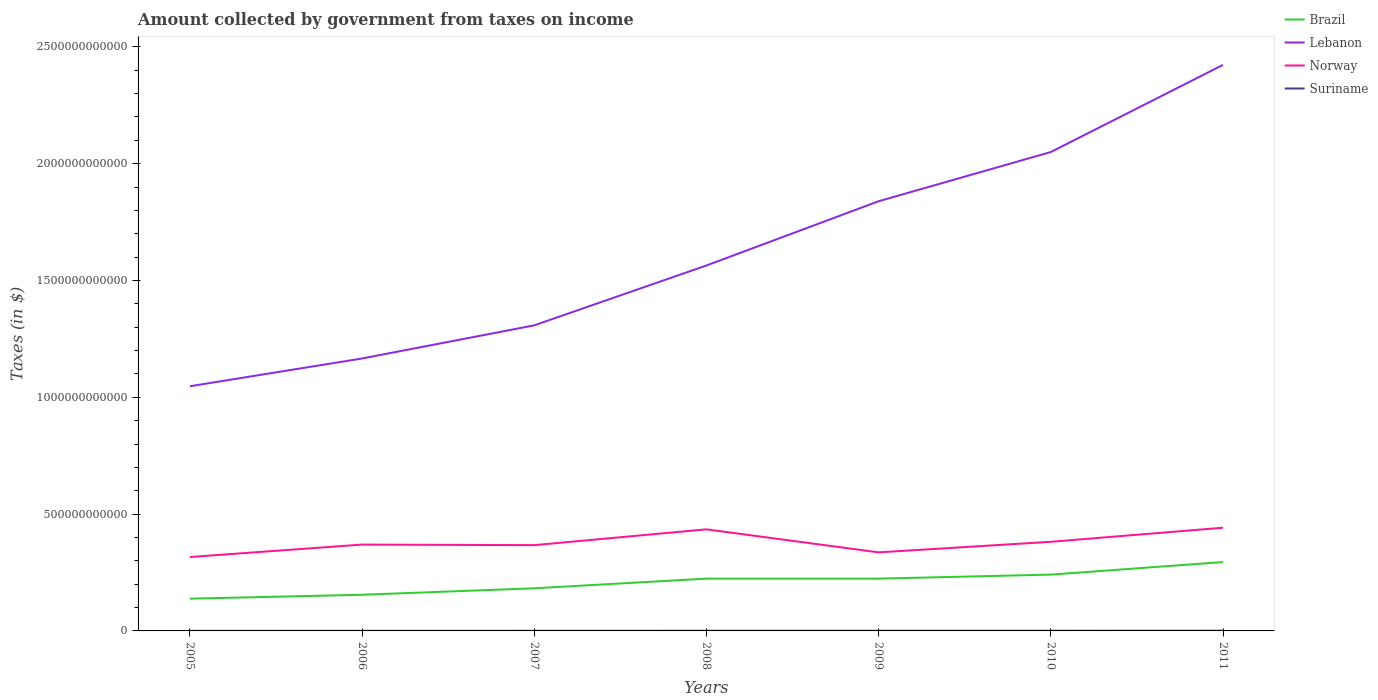How many different coloured lines are there?
Make the answer very short. 4. Across all years, what is the maximum amount collected by government from taxes on income in Lebanon?
Give a very brief answer. 1.05e+12. What is the total amount collected by government from taxes on income in Suriname in the graph?
Offer a very short reply. -3.59e+08. What is the difference between the highest and the second highest amount collected by government from taxes on income in Suriname?
Make the answer very short. 6.50e+08. What is the difference between the highest and the lowest amount collected by government from taxes on income in Brazil?
Offer a very short reply. 4. Is the amount collected by government from taxes on income in Norway strictly greater than the amount collected by government from taxes on income in Brazil over the years?
Your answer should be compact. No. How many lines are there?
Your answer should be compact. 4. How many years are there in the graph?
Offer a very short reply. 7. What is the difference between two consecutive major ticks on the Y-axis?
Provide a succinct answer. 5.00e+11. Does the graph contain any zero values?
Make the answer very short. No. Does the graph contain grids?
Make the answer very short. No. Where does the legend appear in the graph?
Ensure brevity in your answer.  Top right. How are the legend labels stacked?
Offer a very short reply. Vertical. What is the title of the graph?
Keep it short and to the point. Amount collected by government from taxes on income. What is the label or title of the X-axis?
Offer a terse response. Years. What is the label or title of the Y-axis?
Offer a very short reply. Taxes (in $). What is the Taxes (in $) in Brazil in 2005?
Keep it short and to the point. 1.38e+11. What is the Taxes (in $) in Lebanon in 2005?
Your answer should be compact. 1.05e+12. What is the Taxes (in $) of Norway in 2005?
Your response must be concise. 3.16e+11. What is the Taxes (in $) of Suriname in 2005?
Offer a terse response. 3.90e+08. What is the Taxes (in $) in Brazil in 2006?
Your response must be concise. 1.55e+11. What is the Taxes (in $) in Lebanon in 2006?
Provide a short and direct response. 1.17e+12. What is the Taxes (in $) of Norway in 2006?
Provide a succinct answer. 3.70e+11. What is the Taxes (in $) in Suriname in 2006?
Keep it short and to the point. 4.40e+08. What is the Taxes (in $) of Brazil in 2007?
Keep it short and to the point. 1.82e+11. What is the Taxes (in $) in Lebanon in 2007?
Your answer should be very brief. 1.31e+12. What is the Taxes (in $) of Norway in 2007?
Keep it short and to the point. 3.67e+11. What is the Taxes (in $) in Suriname in 2007?
Provide a short and direct response. 5.95e+08. What is the Taxes (in $) of Brazil in 2008?
Offer a very short reply. 2.24e+11. What is the Taxes (in $) of Lebanon in 2008?
Provide a succinct answer. 1.56e+12. What is the Taxes (in $) in Norway in 2008?
Provide a succinct answer. 4.35e+11. What is the Taxes (in $) of Suriname in 2008?
Your answer should be compact. 6.34e+08. What is the Taxes (in $) of Brazil in 2009?
Your response must be concise. 2.24e+11. What is the Taxes (in $) of Lebanon in 2009?
Your answer should be compact. 1.84e+12. What is the Taxes (in $) of Norway in 2009?
Give a very brief answer. 3.36e+11. What is the Taxes (in $) in Suriname in 2009?
Make the answer very short. 7.49e+08. What is the Taxes (in $) in Brazil in 2010?
Keep it short and to the point. 2.41e+11. What is the Taxes (in $) in Lebanon in 2010?
Make the answer very short. 2.05e+12. What is the Taxes (in $) of Norway in 2010?
Provide a succinct answer. 3.81e+11. What is the Taxes (in $) in Suriname in 2010?
Make the answer very short. 7.22e+08. What is the Taxes (in $) of Brazil in 2011?
Offer a terse response. 2.95e+11. What is the Taxes (in $) in Lebanon in 2011?
Your response must be concise. 2.42e+12. What is the Taxes (in $) in Norway in 2011?
Your answer should be compact. 4.42e+11. What is the Taxes (in $) in Suriname in 2011?
Your answer should be very brief. 1.04e+09. Across all years, what is the maximum Taxes (in $) of Brazil?
Your answer should be compact. 2.95e+11. Across all years, what is the maximum Taxes (in $) of Lebanon?
Ensure brevity in your answer.  2.42e+12. Across all years, what is the maximum Taxes (in $) in Norway?
Your answer should be very brief. 4.42e+11. Across all years, what is the maximum Taxes (in $) of Suriname?
Your answer should be very brief. 1.04e+09. Across all years, what is the minimum Taxes (in $) of Brazil?
Make the answer very short. 1.38e+11. Across all years, what is the minimum Taxes (in $) of Lebanon?
Provide a short and direct response. 1.05e+12. Across all years, what is the minimum Taxes (in $) in Norway?
Ensure brevity in your answer.  3.16e+11. Across all years, what is the minimum Taxes (in $) in Suriname?
Keep it short and to the point. 3.90e+08. What is the total Taxes (in $) in Brazil in the graph?
Provide a succinct answer. 1.46e+12. What is the total Taxes (in $) in Lebanon in the graph?
Your answer should be compact. 1.14e+13. What is the total Taxes (in $) of Norway in the graph?
Your answer should be compact. 2.65e+12. What is the total Taxes (in $) of Suriname in the graph?
Offer a terse response. 4.57e+09. What is the difference between the Taxes (in $) in Brazil in 2005 and that in 2006?
Offer a very short reply. -1.67e+1. What is the difference between the Taxes (in $) of Lebanon in 2005 and that in 2006?
Your response must be concise. -1.19e+11. What is the difference between the Taxes (in $) of Norway in 2005 and that in 2006?
Your answer should be compact. -5.32e+1. What is the difference between the Taxes (in $) in Suriname in 2005 and that in 2006?
Provide a succinct answer. -4.96e+07. What is the difference between the Taxes (in $) of Brazil in 2005 and that in 2007?
Keep it short and to the point. -4.44e+1. What is the difference between the Taxes (in $) in Lebanon in 2005 and that in 2007?
Keep it short and to the point. -2.61e+11. What is the difference between the Taxes (in $) in Norway in 2005 and that in 2007?
Your response must be concise. -5.08e+1. What is the difference between the Taxes (in $) of Suriname in 2005 and that in 2007?
Provide a short and direct response. -2.05e+08. What is the difference between the Taxes (in $) of Brazil in 2005 and that in 2008?
Keep it short and to the point. -8.58e+1. What is the difference between the Taxes (in $) in Lebanon in 2005 and that in 2008?
Your answer should be very brief. -5.17e+11. What is the difference between the Taxes (in $) of Norway in 2005 and that in 2008?
Your answer should be very brief. -1.18e+11. What is the difference between the Taxes (in $) of Suriname in 2005 and that in 2008?
Ensure brevity in your answer.  -2.44e+08. What is the difference between the Taxes (in $) in Brazil in 2005 and that in 2009?
Give a very brief answer. -8.58e+1. What is the difference between the Taxes (in $) in Lebanon in 2005 and that in 2009?
Give a very brief answer. -7.92e+11. What is the difference between the Taxes (in $) of Norway in 2005 and that in 2009?
Offer a terse response. -1.99e+1. What is the difference between the Taxes (in $) of Suriname in 2005 and that in 2009?
Offer a very short reply. -3.59e+08. What is the difference between the Taxes (in $) in Brazil in 2005 and that in 2010?
Offer a very short reply. -1.03e+11. What is the difference between the Taxes (in $) in Lebanon in 2005 and that in 2010?
Offer a very short reply. -1.00e+12. What is the difference between the Taxes (in $) of Norway in 2005 and that in 2010?
Keep it short and to the point. -6.51e+1. What is the difference between the Taxes (in $) in Suriname in 2005 and that in 2010?
Give a very brief answer. -3.32e+08. What is the difference between the Taxes (in $) in Brazil in 2005 and that in 2011?
Your answer should be very brief. -1.57e+11. What is the difference between the Taxes (in $) in Lebanon in 2005 and that in 2011?
Your answer should be very brief. -1.38e+12. What is the difference between the Taxes (in $) of Norway in 2005 and that in 2011?
Keep it short and to the point. -1.25e+11. What is the difference between the Taxes (in $) in Suriname in 2005 and that in 2011?
Provide a succinct answer. -6.50e+08. What is the difference between the Taxes (in $) in Brazil in 2006 and that in 2007?
Your answer should be very brief. -2.77e+1. What is the difference between the Taxes (in $) of Lebanon in 2006 and that in 2007?
Ensure brevity in your answer.  -1.42e+11. What is the difference between the Taxes (in $) of Norway in 2006 and that in 2007?
Provide a short and direct response. 2.41e+09. What is the difference between the Taxes (in $) of Suriname in 2006 and that in 2007?
Offer a terse response. -1.55e+08. What is the difference between the Taxes (in $) of Brazil in 2006 and that in 2008?
Keep it short and to the point. -6.91e+1. What is the difference between the Taxes (in $) in Lebanon in 2006 and that in 2008?
Provide a short and direct response. -3.98e+11. What is the difference between the Taxes (in $) in Norway in 2006 and that in 2008?
Offer a terse response. -6.52e+1. What is the difference between the Taxes (in $) in Suriname in 2006 and that in 2008?
Provide a short and direct response. -1.94e+08. What is the difference between the Taxes (in $) in Brazil in 2006 and that in 2009?
Provide a short and direct response. -6.91e+1. What is the difference between the Taxes (in $) in Lebanon in 2006 and that in 2009?
Provide a succinct answer. -6.73e+11. What is the difference between the Taxes (in $) in Norway in 2006 and that in 2009?
Offer a terse response. 3.33e+1. What is the difference between the Taxes (in $) of Suriname in 2006 and that in 2009?
Ensure brevity in your answer.  -3.10e+08. What is the difference between the Taxes (in $) in Brazil in 2006 and that in 2010?
Give a very brief answer. -8.63e+1. What is the difference between the Taxes (in $) of Lebanon in 2006 and that in 2010?
Make the answer very short. -8.84e+11. What is the difference between the Taxes (in $) in Norway in 2006 and that in 2010?
Your answer should be compact. -1.19e+1. What is the difference between the Taxes (in $) of Suriname in 2006 and that in 2010?
Provide a short and direct response. -2.83e+08. What is the difference between the Taxes (in $) of Brazil in 2006 and that in 2011?
Offer a very short reply. -1.40e+11. What is the difference between the Taxes (in $) in Lebanon in 2006 and that in 2011?
Your answer should be very brief. -1.26e+12. What is the difference between the Taxes (in $) of Norway in 2006 and that in 2011?
Provide a succinct answer. -7.22e+1. What is the difference between the Taxes (in $) in Suriname in 2006 and that in 2011?
Give a very brief answer. -6.01e+08. What is the difference between the Taxes (in $) in Brazil in 2007 and that in 2008?
Your response must be concise. -4.14e+1. What is the difference between the Taxes (in $) of Lebanon in 2007 and that in 2008?
Your answer should be very brief. -2.56e+11. What is the difference between the Taxes (in $) in Norway in 2007 and that in 2008?
Make the answer very short. -6.76e+1. What is the difference between the Taxes (in $) in Suriname in 2007 and that in 2008?
Provide a succinct answer. -3.89e+07. What is the difference between the Taxes (in $) in Brazil in 2007 and that in 2009?
Ensure brevity in your answer.  -4.14e+1. What is the difference between the Taxes (in $) of Lebanon in 2007 and that in 2009?
Make the answer very short. -5.31e+11. What is the difference between the Taxes (in $) in Norway in 2007 and that in 2009?
Give a very brief answer. 3.09e+1. What is the difference between the Taxes (in $) in Suriname in 2007 and that in 2009?
Give a very brief answer. -1.55e+08. What is the difference between the Taxes (in $) in Brazil in 2007 and that in 2010?
Your answer should be compact. -5.86e+1. What is the difference between the Taxes (in $) in Lebanon in 2007 and that in 2010?
Your answer should be compact. -7.42e+11. What is the difference between the Taxes (in $) of Norway in 2007 and that in 2010?
Ensure brevity in your answer.  -1.43e+1. What is the difference between the Taxes (in $) of Suriname in 2007 and that in 2010?
Your answer should be compact. -1.28e+08. What is the difference between the Taxes (in $) of Brazil in 2007 and that in 2011?
Make the answer very short. -1.12e+11. What is the difference between the Taxes (in $) of Lebanon in 2007 and that in 2011?
Your response must be concise. -1.11e+12. What is the difference between the Taxes (in $) in Norway in 2007 and that in 2011?
Provide a succinct answer. -7.46e+1. What is the difference between the Taxes (in $) of Suriname in 2007 and that in 2011?
Your response must be concise. -4.46e+08. What is the difference between the Taxes (in $) of Brazil in 2008 and that in 2009?
Your answer should be compact. 1.68e+07. What is the difference between the Taxes (in $) in Lebanon in 2008 and that in 2009?
Provide a short and direct response. -2.75e+11. What is the difference between the Taxes (in $) of Norway in 2008 and that in 2009?
Offer a very short reply. 9.85e+1. What is the difference between the Taxes (in $) of Suriname in 2008 and that in 2009?
Provide a succinct answer. -1.16e+08. What is the difference between the Taxes (in $) of Brazil in 2008 and that in 2010?
Your answer should be very brief. -1.72e+1. What is the difference between the Taxes (in $) in Lebanon in 2008 and that in 2010?
Make the answer very short. -4.86e+11. What is the difference between the Taxes (in $) in Norway in 2008 and that in 2010?
Make the answer very short. 5.33e+1. What is the difference between the Taxes (in $) in Suriname in 2008 and that in 2010?
Ensure brevity in your answer.  -8.88e+07. What is the difference between the Taxes (in $) of Brazil in 2008 and that in 2011?
Provide a short and direct response. -7.09e+1. What is the difference between the Taxes (in $) in Lebanon in 2008 and that in 2011?
Ensure brevity in your answer.  -8.59e+11. What is the difference between the Taxes (in $) of Norway in 2008 and that in 2011?
Your answer should be very brief. -6.99e+09. What is the difference between the Taxes (in $) in Suriname in 2008 and that in 2011?
Provide a short and direct response. -4.07e+08. What is the difference between the Taxes (in $) of Brazil in 2009 and that in 2010?
Provide a succinct answer. -1.72e+1. What is the difference between the Taxes (in $) in Lebanon in 2009 and that in 2010?
Offer a terse response. -2.11e+11. What is the difference between the Taxes (in $) of Norway in 2009 and that in 2010?
Ensure brevity in your answer.  -4.52e+1. What is the difference between the Taxes (in $) of Suriname in 2009 and that in 2010?
Make the answer very short. 2.70e+07. What is the difference between the Taxes (in $) of Brazil in 2009 and that in 2011?
Make the answer very short. -7.09e+1. What is the difference between the Taxes (in $) in Lebanon in 2009 and that in 2011?
Provide a succinct answer. -5.84e+11. What is the difference between the Taxes (in $) in Norway in 2009 and that in 2011?
Make the answer very short. -1.05e+11. What is the difference between the Taxes (in $) of Suriname in 2009 and that in 2011?
Give a very brief answer. -2.91e+08. What is the difference between the Taxes (in $) of Brazil in 2010 and that in 2011?
Your response must be concise. -5.37e+1. What is the difference between the Taxes (in $) in Lebanon in 2010 and that in 2011?
Your answer should be compact. -3.73e+11. What is the difference between the Taxes (in $) in Norway in 2010 and that in 2011?
Ensure brevity in your answer.  -6.03e+1. What is the difference between the Taxes (in $) of Suriname in 2010 and that in 2011?
Offer a very short reply. -3.18e+08. What is the difference between the Taxes (in $) of Brazil in 2005 and the Taxes (in $) of Lebanon in 2006?
Offer a very short reply. -1.03e+12. What is the difference between the Taxes (in $) in Brazil in 2005 and the Taxes (in $) in Norway in 2006?
Make the answer very short. -2.32e+11. What is the difference between the Taxes (in $) in Brazil in 2005 and the Taxes (in $) in Suriname in 2006?
Your answer should be compact. 1.38e+11. What is the difference between the Taxes (in $) in Lebanon in 2005 and the Taxes (in $) in Norway in 2006?
Provide a short and direct response. 6.78e+11. What is the difference between the Taxes (in $) in Lebanon in 2005 and the Taxes (in $) in Suriname in 2006?
Provide a succinct answer. 1.05e+12. What is the difference between the Taxes (in $) of Norway in 2005 and the Taxes (in $) of Suriname in 2006?
Ensure brevity in your answer.  3.16e+11. What is the difference between the Taxes (in $) in Brazil in 2005 and the Taxes (in $) in Lebanon in 2007?
Your answer should be compact. -1.17e+12. What is the difference between the Taxes (in $) in Brazil in 2005 and the Taxes (in $) in Norway in 2007?
Ensure brevity in your answer.  -2.29e+11. What is the difference between the Taxes (in $) of Brazil in 2005 and the Taxes (in $) of Suriname in 2007?
Your response must be concise. 1.37e+11. What is the difference between the Taxes (in $) of Lebanon in 2005 and the Taxes (in $) of Norway in 2007?
Offer a very short reply. 6.80e+11. What is the difference between the Taxes (in $) of Lebanon in 2005 and the Taxes (in $) of Suriname in 2007?
Your response must be concise. 1.05e+12. What is the difference between the Taxes (in $) in Norway in 2005 and the Taxes (in $) in Suriname in 2007?
Your answer should be very brief. 3.16e+11. What is the difference between the Taxes (in $) of Brazil in 2005 and the Taxes (in $) of Lebanon in 2008?
Offer a terse response. -1.43e+12. What is the difference between the Taxes (in $) of Brazil in 2005 and the Taxes (in $) of Norway in 2008?
Your answer should be compact. -2.97e+11. What is the difference between the Taxes (in $) of Brazil in 2005 and the Taxes (in $) of Suriname in 2008?
Keep it short and to the point. 1.37e+11. What is the difference between the Taxes (in $) in Lebanon in 2005 and the Taxes (in $) in Norway in 2008?
Give a very brief answer. 6.13e+11. What is the difference between the Taxes (in $) of Lebanon in 2005 and the Taxes (in $) of Suriname in 2008?
Make the answer very short. 1.05e+12. What is the difference between the Taxes (in $) in Norway in 2005 and the Taxes (in $) in Suriname in 2008?
Make the answer very short. 3.16e+11. What is the difference between the Taxes (in $) of Brazil in 2005 and the Taxes (in $) of Lebanon in 2009?
Offer a very short reply. -1.70e+12. What is the difference between the Taxes (in $) of Brazil in 2005 and the Taxes (in $) of Norway in 2009?
Your answer should be very brief. -1.98e+11. What is the difference between the Taxes (in $) of Brazil in 2005 and the Taxes (in $) of Suriname in 2009?
Offer a terse response. 1.37e+11. What is the difference between the Taxes (in $) of Lebanon in 2005 and the Taxes (in $) of Norway in 2009?
Your answer should be very brief. 7.11e+11. What is the difference between the Taxes (in $) in Lebanon in 2005 and the Taxes (in $) in Suriname in 2009?
Your answer should be compact. 1.05e+12. What is the difference between the Taxes (in $) in Norway in 2005 and the Taxes (in $) in Suriname in 2009?
Your answer should be compact. 3.16e+11. What is the difference between the Taxes (in $) in Brazil in 2005 and the Taxes (in $) in Lebanon in 2010?
Offer a very short reply. -1.91e+12. What is the difference between the Taxes (in $) in Brazil in 2005 and the Taxes (in $) in Norway in 2010?
Give a very brief answer. -2.43e+11. What is the difference between the Taxes (in $) of Brazil in 2005 and the Taxes (in $) of Suriname in 2010?
Keep it short and to the point. 1.37e+11. What is the difference between the Taxes (in $) in Lebanon in 2005 and the Taxes (in $) in Norway in 2010?
Give a very brief answer. 6.66e+11. What is the difference between the Taxes (in $) of Lebanon in 2005 and the Taxes (in $) of Suriname in 2010?
Your response must be concise. 1.05e+12. What is the difference between the Taxes (in $) in Norway in 2005 and the Taxes (in $) in Suriname in 2010?
Give a very brief answer. 3.16e+11. What is the difference between the Taxes (in $) in Brazil in 2005 and the Taxes (in $) in Lebanon in 2011?
Keep it short and to the point. -2.28e+12. What is the difference between the Taxes (in $) in Brazil in 2005 and the Taxes (in $) in Norway in 2011?
Ensure brevity in your answer.  -3.04e+11. What is the difference between the Taxes (in $) in Brazil in 2005 and the Taxes (in $) in Suriname in 2011?
Your response must be concise. 1.37e+11. What is the difference between the Taxes (in $) in Lebanon in 2005 and the Taxes (in $) in Norway in 2011?
Your response must be concise. 6.06e+11. What is the difference between the Taxes (in $) of Lebanon in 2005 and the Taxes (in $) of Suriname in 2011?
Your response must be concise. 1.05e+12. What is the difference between the Taxes (in $) in Norway in 2005 and the Taxes (in $) in Suriname in 2011?
Provide a short and direct response. 3.15e+11. What is the difference between the Taxes (in $) of Brazil in 2006 and the Taxes (in $) of Lebanon in 2007?
Offer a very short reply. -1.15e+12. What is the difference between the Taxes (in $) in Brazil in 2006 and the Taxes (in $) in Norway in 2007?
Give a very brief answer. -2.12e+11. What is the difference between the Taxes (in $) in Brazil in 2006 and the Taxes (in $) in Suriname in 2007?
Your answer should be compact. 1.54e+11. What is the difference between the Taxes (in $) of Lebanon in 2006 and the Taxes (in $) of Norway in 2007?
Make the answer very short. 7.99e+11. What is the difference between the Taxes (in $) in Lebanon in 2006 and the Taxes (in $) in Suriname in 2007?
Your answer should be very brief. 1.17e+12. What is the difference between the Taxes (in $) in Norway in 2006 and the Taxes (in $) in Suriname in 2007?
Offer a very short reply. 3.69e+11. What is the difference between the Taxes (in $) in Brazil in 2006 and the Taxes (in $) in Lebanon in 2008?
Your answer should be very brief. -1.41e+12. What is the difference between the Taxes (in $) in Brazil in 2006 and the Taxes (in $) in Norway in 2008?
Give a very brief answer. -2.80e+11. What is the difference between the Taxes (in $) in Brazil in 2006 and the Taxes (in $) in Suriname in 2008?
Your answer should be compact. 1.54e+11. What is the difference between the Taxes (in $) of Lebanon in 2006 and the Taxes (in $) of Norway in 2008?
Your answer should be very brief. 7.31e+11. What is the difference between the Taxes (in $) of Lebanon in 2006 and the Taxes (in $) of Suriname in 2008?
Provide a short and direct response. 1.17e+12. What is the difference between the Taxes (in $) in Norway in 2006 and the Taxes (in $) in Suriname in 2008?
Make the answer very short. 3.69e+11. What is the difference between the Taxes (in $) in Brazil in 2006 and the Taxes (in $) in Lebanon in 2009?
Your answer should be very brief. -1.68e+12. What is the difference between the Taxes (in $) in Brazil in 2006 and the Taxes (in $) in Norway in 2009?
Keep it short and to the point. -1.82e+11. What is the difference between the Taxes (in $) in Brazil in 2006 and the Taxes (in $) in Suriname in 2009?
Your answer should be very brief. 1.54e+11. What is the difference between the Taxes (in $) in Lebanon in 2006 and the Taxes (in $) in Norway in 2009?
Offer a terse response. 8.30e+11. What is the difference between the Taxes (in $) in Lebanon in 2006 and the Taxes (in $) in Suriname in 2009?
Provide a succinct answer. 1.17e+12. What is the difference between the Taxes (in $) in Norway in 2006 and the Taxes (in $) in Suriname in 2009?
Offer a very short reply. 3.69e+11. What is the difference between the Taxes (in $) in Brazil in 2006 and the Taxes (in $) in Lebanon in 2010?
Offer a terse response. -1.90e+12. What is the difference between the Taxes (in $) in Brazil in 2006 and the Taxes (in $) in Norway in 2010?
Your response must be concise. -2.27e+11. What is the difference between the Taxes (in $) in Brazil in 2006 and the Taxes (in $) in Suriname in 2010?
Give a very brief answer. 1.54e+11. What is the difference between the Taxes (in $) in Lebanon in 2006 and the Taxes (in $) in Norway in 2010?
Offer a terse response. 7.85e+11. What is the difference between the Taxes (in $) of Lebanon in 2006 and the Taxes (in $) of Suriname in 2010?
Your answer should be very brief. 1.17e+12. What is the difference between the Taxes (in $) in Norway in 2006 and the Taxes (in $) in Suriname in 2010?
Provide a succinct answer. 3.69e+11. What is the difference between the Taxes (in $) in Brazil in 2006 and the Taxes (in $) in Lebanon in 2011?
Give a very brief answer. -2.27e+12. What is the difference between the Taxes (in $) in Brazil in 2006 and the Taxes (in $) in Norway in 2011?
Your answer should be compact. -2.87e+11. What is the difference between the Taxes (in $) of Brazil in 2006 and the Taxes (in $) of Suriname in 2011?
Give a very brief answer. 1.54e+11. What is the difference between the Taxes (in $) in Lebanon in 2006 and the Taxes (in $) in Norway in 2011?
Provide a succinct answer. 7.24e+11. What is the difference between the Taxes (in $) in Lebanon in 2006 and the Taxes (in $) in Suriname in 2011?
Keep it short and to the point. 1.17e+12. What is the difference between the Taxes (in $) of Norway in 2006 and the Taxes (in $) of Suriname in 2011?
Give a very brief answer. 3.69e+11. What is the difference between the Taxes (in $) of Brazil in 2007 and the Taxes (in $) of Lebanon in 2008?
Ensure brevity in your answer.  -1.38e+12. What is the difference between the Taxes (in $) of Brazil in 2007 and the Taxes (in $) of Norway in 2008?
Your answer should be compact. -2.52e+11. What is the difference between the Taxes (in $) of Brazil in 2007 and the Taxes (in $) of Suriname in 2008?
Your answer should be very brief. 1.82e+11. What is the difference between the Taxes (in $) of Lebanon in 2007 and the Taxes (in $) of Norway in 2008?
Give a very brief answer. 8.73e+11. What is the difference between the Taxes (in $) in Lebanon in 2007 and the Taxes (in $) in Suriname in 2008?
Your answer should be very brief. 1.31e+12. What is the difference between the Taxes (in $) of Norway in 2007 and the Taxes (in $) of Suriname in 2008?
Provide a short and direct response. 3.67e+11. What is the difference between the Taxes (in $) in Brazil in 2007 and the Taxes (in $) in Lebanon in 2009?
Your answer should be compact. -1.66e+12. What is the difference between the Taxes (in $) of Brazil in 2007 and the Taxes (in $) of Norway in 2009?
Your answer should be very brief. -1.54e+11. What is the difference between the Taxes (in $) in Brazil in 2007 and the Taxes (in $) in Suriname in 2009?
Offer a very short reply. 1.82e+11. What is the difference between the Taxes (in $) of Lebanon in 2007 and the Taxes (in $) of Norway in 2009?
Make the answer very short. 9.72e+11. What is the difference between the Taxes (in $) in Lebanon in 2007 and the Taxes (in $) in Suriname in 2009?
Your response must be concise. 1.31e+12. What is the difference between the Taxes (in $) in Norway in 2007 and the Taxes (in $) in Suriname in 2009?
Provide a short and direct response. 3.66e+11. What is the difference between the Taxes (in $) in Brazil in 2007 and the Taxes (in $) in Lebanon in 2010?
Make the answer very short. -1.87e+12. What is the difference between the Taxes (in $) in Brazil in 2007 and the Taxes (in $) in Norway in 2010?
Provide a short and direct response. -1.99e+11. What is the difference between the Taxes (in $) in Brazil in 2007 and the Taxes (in $) in Suriname in 2010?
Make the answer very short. 1.82e+11. What is the difference between the Taxes (in $) in Lebanon in 2007 and the Taxes (in $) in Norway in 2010?
Offer a terse response. 9.27e+11. What is the difference between the Taxes (in $) of Lebanon in 2007 and the Taxes (in $) of Suriname in 2010?
Your response must be concise. 1.31e+12. What is the difference between the Taxes (in $) of Norway in 2007 and the Taxes (in $) of Suriname in 2010?
Make the answer very short. 3.66e+11. What is the difference between the Taxes (in $) of Brazil in 2007 and the Taxes (in $) of Lebanon in 2011?
Your answer should be compact. -2.24e+12. What is the difference between the Taxes (in $) of Brazil in 2007 and the Taxes (in $) of Norway in 2011?
Ensure brevity in your answer.  -2.59e+11. What is the difference between the Taxes (in $) in Brazil in 2007 and the Taxes (in $) in Suriname in 2011?
Offer a very short reply. 1.81e+11. What is the difference between the Taxes (in $) of Lebanon in 2007 and the Taxes (in $) of Norway in 2011?
Your response must be concise. 8.66e+11. What is the difference between the Taxes (in $) of Lebanon in 2007 and the Taxes (in $) of Suriname in 2011?
Provide a short and direct response. 1.31e+12. What is the difference between the Taxes (in $) of Norway in 2007 and the Taxes (in $) of Suriname in 2011?
Provide a succinct answer. 3.66e+11. What is the difference between the Taxes (in $) of Brazil in 2008 and the Taxes (in $) of Lebanon in 2009?
Your response must be concise. -1.62e+12. What is the difference between the Taxes (in $) of Brazil in 2008 and the Taxes (in $) of Norway in 2009?
Provide a short and direct response. -1.12e+11. What is the difference between the Taxes (in $) of Brazil in 2008 and the Taxes (in $) of Suriname in 2009?
Your answer should be compact. 2.23e+11. What is the difference between the Taxes (in $) in Lebanon in 2008 and the Taxes (in $) in Norway in 2009?
Provide a short and direct response. 1.23e+12. What is the difference between the Taxes (in $) in Lebanon in 2008 and the Taxes (in $) in Suriname in 2009?
Ensure brevity in your answer.  1.56e+12. What is the difference between the Taxes (in $) of Norway in 2008 and the Taxes (in $) of Suriname in 2009?
Give a very brief answer. 4.34e+11. What is the difference between the Taxes (in $) of Brazil in 2008 and the Taxes (in $) of Lebanon in 2010?
Keep it short and to the point. -1.83e+12. What is the difference between the Taxes (in $) in Brazil in 2008 and the Taxes (in $) in Norway in 2010?
Keep it short and to the point. -1.58e+11. What is the difference between the Taxes (in $) of Brazil in 2008 and the Taxes (in $) of Suriname in 2010?
Provide a succinct answer. 2.23e+11. What is the difference between the Taxes (in $) in Lebanon in 2008 and the Taxes (in $) in Norway in 2010?
Your answer should be very brief. 1.18e+12. What is the difference between the Taxes (in $) of Lebanon in 2008 and the Taxes (in $) of Suriname in 2010?
Keep it short and to the point. 1.56e+12. What is the difference between the Taxes (in $) in Norway in 2008 and the Taxes (in $) in Suriname in 2010?
Provide a succinct answer. 4.34e+11. What is the difference between the Taxes (in $) in Brazil in 2008 and the Taxes (in $) in Lebanon in 2011?
Provide a short and direct response. -2.20e+12. What is the difference between the Taxes (in $) in Brazil in 2008 and the Taxes (in $) in Norway in 2011?
Provide a short and direct response. -2.18e+11. What is the difference between the Taxes (in $) of Brazil in 2008 and the Taxes (in $) of Suriname in 2011?
Your answer should be very brief. 2.23e+11. What is the difference between the Taxes (in $) in Lebanon in 2008 and the Taxes (in $) in Norway in 2011?
Ensure brevity in your answer.  1.12e+12. What is the difference between the Taxes (in $) in Lebanon in 2008 and the Taxes (in $) in Suriname in 2011?
Keep it short and to the point. 1.56e+12. What is the difference between the Taxes (in $) in Norway in 2008 and the Taxes (in $) in Suriname in 2011?
Ensure brevity in your answer.  4.34e+11. What is the difference between the Taxes (in $) of Brazil in 2009 and the Taxes (in $) of Lebanon in 2010?
Make the answer very short. -1.83e+12. What is the difference between the Taxes (in $) in Brazil in 2009 and the Taxes (in $) in Norway in 2010?
Keep it short and to the point. -1.58e+11. What is the difference between the Taxes (in $) of Brazil in 2009 and the Taxes (in $) of Suriname in 2010?
Provide a succinct answer. 2.23e+11. What is the difference between the Taxes (in $) of Lebanon in 2009 and the Taxes (in $) of Norway in 2010?
Offer a terse response. 1.46e+12. What is the difference between the Taxes (in $) of Lebanon in 2009 and the Taxes (in $) of Suriname in 2010?
Your response must be concise. 1.84e+12. What is the difference between the Taxes (in $) of Norway in 2009 and the Taxes (in $) of Suriname in 2010?
Provide a short and direct response. 3.36e+11. What is the difference between the Taxes (in $) of Brazil in 2009 and the Taxes (in $) of Lebanon in 2011?
Ensure brevity in your answer.  -2.20e+12. What is the difference between the Taxes (in $) in Brazil in 2009 and the Taxes (in $) in Norway in 2011?
Your response must be concise. -2.18e+11. What is the difference between the Taxes (in $) in Brazil in 2009 and the Taxes (in $) in Suriname in 2011?
Make the answer very short. 2.23e+11. What is the difference between the Taxes (in $) in Lebanon in 2009 and the Taxes (in $) in Norway in 2011?
Make the answer very short. 1.40e+12. What is the difference between the Taxes (in $) of Lebanon in 2009 and the Taxes (in $) of Suriname in 2011?
Make the answer very short. 1.84e+12. What is the difference between the Taxes (in $) of Norway in 2009 and the Taxes (in $) of Suriname in 2011?
Offer a very short reply. 3.35e+11. What is the difference between the Taxes (in $) of Brazil in 2010 and the Taxes (in $) of Lebanon in 2011?
Your answer should be very brief. -2.18e+12. What is the difference between the Taxes (in $) in Brazil in 2010 and the Taxes (in $) in Norway in 2011?
Offer a terse response. -2.01e+11. What is the difference between the Taxes (in $) in Brazil in 2010 and the Taxes (in $) in Suriname in 2011?
Make the answer very short. 2.40e+11. What is the difference between the Taxes (in $) of Lebanon in 2010 and the Taxes (in $) of Norway in 2011?
Offer a very short reply. 1.61e+12. What is the difference between the Taxes (in $) of Lebanon in 2010 and the Taxes (in $) of Suriname in 2011?
Your answer should be very brief. 2.05e+12. What is the difference between the Taxes (in $) of Norway in 2010 and the Taxes (in $) of Suriname in 2011?
Keep it short and to the point. 3.80e+11. What is the average Taxes (in $) in Brazil per year?
Your answer should be very brief. 2.08e+11. What is the average Taxes (in $) of Lebanon per year?
Your answer should be compact. 1.63e+12. What is the average Taxes (in $) in Norway per year?
Your response must be concise. 3.78e+11. What is the average Taxes (in $) of Suriname per year?
Your answer should be compact. 6.53e+08. In the year 2005, what is the difference between the Taxes (in $) in Brazil and Taxes (in $) in Lebanon?
Give a very brief answer. -9.09e+11. In the year 2005, what is the difference between the Taxes (in $) of Brazil and Taxes (in $) of Norway?
Your answer should be compact. -1.78e+11. In the year 2005, what is the difference between the Taxes (in $) in Brazil and Taxes (in $) in Suriname?
Ensure brevity in your answer.  1.38e+11. In the year 2005, what is the difference between the Taxes (in $) in Lebanon and Taxes (in $) in Norway?
Your answer should be very brief. 7.31e+11. In the year 2005, what is the difference between the Taxes (in $) of Lebanon and Taxes (in $) of Suriname?
Your answer should be compact. 1.05e+12. In the year 2005, what is the difference between the Taxes (in $) of Norway and Taxes (in $) of Suriname?
Provide a short and direct response. 3.16e+11. In the year 2006, what is the difference between the Taxes (in $) of Brazil and Taxes (in $) of Lebanon?
Keep it short and to the point. -1.01e+12. In the year 2006, what is the difference between the Taxes (in $) in Brazil and Taxes (in $) in Norway?
Provide a short and direct response. -2.15e+11. In the year 2006, what is the difference between the Taxes (in $) of Brazil and Taxes (in $) of Suriname?
Make the answer very short. 1.54e+11. In the year 2006, what is the difference between the Taxes (in $) of Lebanon and Taxes (in $) of Norway?
Your answer should be very brief. 7.97e+11. In the year 2006, what is the difference between the Taxes (in $) of Lebanon and Taxes (in $) of Suriname?
Your answer should be very brief. 1.17e+12. In the year 2006, what is the difference between the Taxes (in $) of Norway and Taxes (in $) of Suriname?
Offer a terse response. 3.69e+11. In the year 2007, what is the difference between the Taxes (in $) in Brazil and Taxes (in $) in Lebanon?
Your answer should be compact. -1.13e+12. In the year 2007, what is the difference between the Taxes (in $) of Brazil and Taxes (in $) of Norway?
Provide a short and direct response. -1.85e+11. In the year 2007, what is the difference between the Taxes (in $) of Brazil and Taxes (in $) of Suriname?
Provide a short and direct response. 1.82e+11. In the year 2007, what is the difference between the Taxes (in $) of Lebanon and Taxes (in $) of Norway?
Give a very brief answer. 9.41e+11. In the year 2007, what is the difference between the Taxes (in $) of Lebanon and Taxes (in $) of Suriname?
Offer a very short reply. 1.31e+12. In the year 2007, what is the difference between the Taxes (in $) in Norway and Taxes (in $) in Suriname?
Give a very brief answer. 3.67e+11. In the year 2008, what is the difference between the Taxes (in $) in Brazil and Taxes (in $) in Lebanon?
Provide a succinct answer. -1.34e+12. In the year 2008, what is the difference between the Taxes (in $) in Brazil and Taxes (in $) in Norway?
Keep it short and to the point. -2.11e+11. In the year 2008, what is the difference between the Taxes (in $) in Brazil and Taxes (in $) in Suriname?
Your answer should be compact. 2.23e+11. In the year 2008, what is the difference between the Taxes (in $) in Lebanon and Taxes (in $) in Norway?
Your response must be concise. 1.13e+12. In the year 2008, what is the difference between the Taxes (in $) in Lebanon and Taxes (in $) in Suriname?
Provide a short and direct response. 1.56e+12. In the year 2008, what is the difference between the Taxes (in $) in Norway and Taxes (in $) in Suriname?
Offer a very short reply. 4.34e+11. In the year 2009, what is the difference between the Taxes (in $) of Brazil and Taxes (in $) of Lebanon?
Keep it short and to the point. -1.62e+12. In the year 2009, what is the difference between the Taxes (in $) of Brazil and Taxes (in $) of Norway?
Make the answer very short. -1.12e+11. In the year 2009, what is the difference between the Taxes (in $) in Brazil and Taxes (in $) in Suriname?
Your answer should be very brief. 2.23e+11. In the year 2009, what is the difference between the Taxes (in $) of Lebanon and Taxes (in $) of Norway?
Your answer should be very brief. 1.50e+12. In the year 2009, what is the difference between the Taxes (in $) of Lebanon and Taxes (in $) of Suriname?
Ensure brevity in your answer.  1.84e+12. In the year 2009, what is the difference between the Taxes (in $) of Norway and Taxes (in $) of Suriname?
Give a very brief answer. 3.36e+11. In the year 2010, what is the difference between the Taxes (in $) of Brazil and Taxes (in $) of Lebanon?
Give a very brief answer. -1.81e+12. In the year 2010, what is the difference between the Taxes (in $) in Brazil and Taxes (in $) in Norway?
Give a very brief answer. -1.40e+11. In the year 2010, what is the difference between the Taxes (in $) in Brazil and Taxes (in $) in Suriname?
Keep it short and to the point. 2.40e+11. In the year 2010, what is the difference between the Taxes (in $) in Lebanon and Taxes (in $) in Norway?
Provide a succinct answer. 1.67e+12. In the year 2010, what is the difference between the Taxes (in $) in Lebanon and Taxes (in $) in Suriname?
Your answer should be compact. 2.05e+12. In the year 2010, what is the difference between the Taxes (in $) in Norway and Taxes (in $) in Suriname?
Make the answer very short. 3.81e+11. In the year 2011, what is the difference between the Taxes (in $) in Brazil and Taxes (in $) in Lebanon?
Ensure brevity in your answer.  -2.13e+12. In the year 2011, what is the difference between the Taxes (in $) of Brazil and Taxes (in $) of Norway?
Your response must be concise. -1.47e+11. In the year 2011, what is the difference between the Taxes (in $) of Brazil and Taxes (in $) of Suriname?
Keep it short and to the point. 2.94e+11. In the year 2011, what is the difference between the Taxes (in $) of Lebanon and Taxes (in $) of Norway?
Make the answer very short. 1.98e+12. In the year 2011, what is the difference between the Taxes (in $) of Lebanon and Taxes (in $) of Suriname?
Give a very brief answer. 2.42e+12. In the year 2011, what is the difference between the Taxes (in $) of Norway and Taxes (in $) of Suriname?
Make the answer very short. 4.41e+11. What is the ratio of the Taxes (in $) of Brazil in 2005 to that in 2006?
Give a very brief answer. 0.89. What is the ratio of the Taxes (in $) in Lebanon in 2005 to that in 2006?
Provide a succinct answer. 0.9. What is the ratio of the Taxes (in $) in Norway in 2005 to that in 2006?
Provide a short and direct response. 0.86. What is the ratio of the Taxes (in $) in Suriname in 2005 to that in 2006?
Ensure brevity in your answer.  0.89. What is the ratio of the Taxes (in $) of Brazil in 2005 to that in 2007?
Offer a very short reply. 0.76. What is the ratio of the Taxes (in $) in Lebanon in 2005 to that in 2007?
Provide a short and direct response. 0.8. What is the ratio of the Taxes (in $) in Norway in 2005 to that in 2007?
Offer a terse response. 0.86. What is the ratio of the Taxes (in $) in Suriname in 2005 to that in 2007?
Offer a very short reply. 0.66. What is the ratio of the Taxes (in $) of Brazil in 2005 to that in 2008?
Provide a succinct answer. 0.62. What is the ratio of the Taxes (in $) in Lebanon in 2005 to that in 2008?
Keep it short and to the point. 0.67. What is the ratio of the Taxes (in $) in Norway in 2005 to that in 2008?
Your response must be concise. 0.73. What is the ratio of the Taxes (in $) of Suriname in 2005 to that in 2008?
Your answer should be very brief. 0.62. What is the ratio of the Taxes (in $) in Brazil in 2005 to that in 2009?
Your answer should be compact. 0.62. What is the ratio of the Taxes (in $) in Lebanon in 2005 to that in 2009?
Ensure brevity in your answer.  0.57. What is the ratio of the Taxes (in $) in Norway in 2005 to that in 2009?
Provide a short and direct response. 0.94. What is the ratio of the Taxes (in $) of Suriname in 2005 to that in 2009?
Offer a terse response. 0.52. What is the ratio of the Taxes (in $) of Brazil in 2005 to that in 2010?
Your answer should be very brief. 0.57. What is the ratio of the Taxes (in $) in Lebanon in 2005 to that in 2010?
Provide a succinct answer. 0.51. What is the ratio of the Taxes (in $) of Norway in 2005 to that in 2010?
Ensure brevity in your answer.  0.83. What is the ratio of the Taxes (in $) of Suriname in 2005 to that in 2010?
Your response must be concise. 0.54. What is the ratio of the Taxes (in $) in Brazil in 2005 to that in 2011?
Your answer should be very brief. 0.47. What is the ratio of the Taxes (in $) of Lebanon in 2005 to that in 2011?
Your response must be concise. 0.43. What is the ratio of the Taxes (in $) of Norway in 2005 to that in 2011?
Ensure brevity in your answer.  0.72. What is the ratio of the Taxes (in $) in Suriname in 2005 to that in 2011?
Your answer should be compact. 0.37. What is the ratio of the Taxes (in $) of Brazil in 2006 to that in 2007?
Give a very brief answer. 0.85. What is the ratio of the Taxes (in $) of Lebanon in 2006 to that in 2007?
Your response must be concise. 0.89. What is the ratio of the Taxes (in $) of Norway in 2006 to that in 2007?
Provide a succinct answer. 1.01. What is the ratio of the Taxes (in $) in Suriname in 2006 to that in 2007?
Your answer should be compact. 0.74. What is the ratio of the Taxes (in $) of Brazil in 2006 to that in 2008?
Your answer should be very brief. 0.69. What is the ratio of the Taxes (in $) in Lebanon in 2006 to that in 2008?
Provide a short and direct response. 0.75. What is the ratio of the Taxes (in $) of Norway in 2006 to that in 2008?
Make the answer very short. 0.85. What is the ratio of the Taxes (in $) in Suriname in 2006 to that in 2008?
Offer a terse response. 0.69. What is the ratio of the Taxes (in $) in Brazil in 2006 to that in 2009?
Your answer should be very brief. 0.69. What is the ratio of the Taxes (in $) in Lebanon in 2006 to that in 2009?
Keep it short and to the point. 0.63. What is the ratio of the Taxes (in $) of Norway in 2006 to that in 2009?
Your answer should be very brief. 1.1. What is the ratio of the Taxes (in $) of Suriname in 2006 to that in 2009?
Give a very brief answer. 0.59. What is the ratio of the Taxes (in $) in Brazil in 2006 to that in 2010?
Your answer should be compact. 0.64. What is the ratio of the Taxes (in $) of Lebanon in 2006 to that in 2010?
Your answer should be very brief. 0.57. What is the ratio of the Taxes (in $) of Norway in 2006 to that in 2010?
Ensure brevity in your answer.  0.97. What is the ratio of the Taxes (in $) of Suriname in 2006 to that in 2010?
Make the answer very short. 0.61. What is the ratio of the Taxes (in $) of Brazil in 2006 to that in 2011?
Offer a terse response. 0.53. What is the ratio of the Taxes (in $) of Lebanon in 2006 to that in 2011?
Offer a very short reply. 0.48. What is the ratio of the Taxes (in $) in Norway in 2006 to that in 2011?
Make the answer very short. 0.84. What is the ratio of the Taxes (in $) in Suriname in 2006 to that in 2011?
Offer a terse response. 0.42. What is the ratio of the Taxes (in $) of Brazil in 2007 to that in 2008?
Offer a very short reply. 0.82. What is the ratio of the Taxes (in $) of Lebanon in 2007 to that in 2008?
Keep it short and to the point. 0.84. What is the ratio of the Taxes (in $) of Norway in 2007 to that in 2008?
Your answer should be very brief. 0.84. What is the ratio of the Taxes (in $) in Suriname in 2007 to that in 2008?
Provide a succinct answer. 0.94. What is the ratio of the Taxes (in $) in Brazil in 2007 to that in 2009?
Ensure brevity in your answer.  0.82. What is the ratio of the Taxes (in $) of Lebanon in 2007 to that in 2009?
Offer a terse response. 0.71. What is the ratio of the Taxes (in $) of Norway in 2007 to that in 2009?
Keep it short and to the point. 1.09. What is the ratio of the Taxes (in $) in Suriname in 2007 to that in 2009?
Make the answer very short. 0.79. What is the ratio of the Taxes (in $) of Brazil in 2007 to that in 2010?
Your answer should be compact. 0.76. What is the ratio of the Taxes (in $) in Lebanon in 2007 to that in 2010?
Provide a short and direct response. 0.64. What is the ratio of the Taxes (in $) of Norway in 2007 to that in 2010?
Provide a short and direct response. 0.96. What is the ratio of the Taxes (in $) of Suriname in 2007 to that in 2010?
Provide a short and direct response. 0.82. What is the ratio of the Taxes (in $) of Brazil in 2007 to that in 2011?
Ensure brevity in your answer.  0.62. What is the ratio of the Taxes (in $) in Lebanon in 2007 to that in 2011?
Your response must be concise. 0.54. What is the ratio of the Taxes (in $) of Norway in 2007 to that in 2011?
Your answer should be compact. 0.83. What is the ratio of the Taxes (in $) of Suriname in 2007 to that in 2011?
Make the answer very short. 0.57. What is the ratio of the Taxes (in $) in Brazil in 2008 to that in 2009?
Make the answer very short. 1. What is the ratio of the Taxes (in $) of Lebanon in 2008 to that in 2009?
Offer a very short reply. 0.85. What is the ratio of the Taxes (in $) of Norway in 2008 to that in 2009?
Offer a very short reply. 1.29. What is the ratio of the Taxes (in $) of Suriname in 2008 to that in 2009?
Give a very brief answer. 0.85. What is the ratio of the Taxes (in $) in Brazil in 2008 to that in 2010?
Offer a very short reply. 0.93. What is the ratio of the Taxes (in $) in Lebanon in 2008 to that in 2010?
Keep it short and to the point. 0.76. What is the ratio of the Taxes (in $) in Norway in 2008 to that in 2010?
Offer a terse response. 1.14. What is the ratio of the Taxes (in $) in Suriname in 2008 to that in 2010?
Give a very brief answer. 0.88. What is the ratio of the Taxes (in $) of Brazil in 2008 to that in 2011?
Offer a terse response. 0.76. What is the ratio of the Taxes (in $) in Lebanon in 2008 to that in 2011?
Your answer should be compact. 0.65. What is the ratio of the Taxes (in $) of Norway in 2008 to that in 2011?
Offer a very short reply. 0.98. What is the ratio of the Taxes (in $) of Suriname in 2008 to that in 2011?
Offer a very short reply. 0.61. What is the ratio of the Taxes (in $) in Brazil in 2009 to that in 2010?
Keep it short and to the point. 0.93. What is the ratio of the Taxes (in $) in Lebanon in 2009 to that in 2010?
Make the answer very short. 0.9. What is the ratio of the Taxes (in $) in Norway in 2009 to that in 2010?
Make the answer very short. 0.88. What is the ratio of the Taxes (in $) in Suriname in 2009 to that in 2010?
Your answer should be compact. 1.04. What is the ratio of the Taxes (in $) of Brazil in 2009 to that in 2011?
Ensure brevity in your answer.  0.76. What is the ratio of the Taxes (in $) in Lebanon in 2009 to that in 2011?
Offer a very short reply. 0.76. What is the ratio of the Taxes (in $) in Norway in 2009 to that in 2011?
Ensure brevity in your answer.  0.76. What is the ratio of the Taxes (in $) of Suriname in 2009 to that in 2011?
Give a very brief answer. 0.72. What is the ratio of the Taxes (in $) of Brazil in 2010 to that in 2011?
Your response must be concise. 0.82. What is the ratio of the Taxes (in $) in Lebanon in 2010 to that in 2011?
Offer a very short reply. 0.85. What is the ratio of the Taxes (in $) of Norway in 2010 to that in 2011?
Provide a short and direct response. 0.86. What is the ratio of the Taxes (in $) of Suriname in 2010 to that in 2011?
Keep it short and to the point. 0.69. What is the difference between the highest and the second highest Taxes (in $) of Brazil?
Provide a short and direct response. 5.37e+1. What is the difference between the highest and the second highest Taxes (in $) in Lebanon?
Provide a short and direct response. 3.73e+11. What is the difference between the highest and the second highest Taxes (in $) in Norway?
Ensure brevity in your answer.  6.99e+09. What is the difference between the highest and the second highest Taxes (in $) of Suriname?
Keep it short and to the point. 2.91e+08. What is the difference between the highest and the lowest Taxes (in $) of Brazil?
Give a very brief answer. 1.57e+11. What is the difference between the highest and the lowest Taxes (in $) in Lebanon?
Provide a short and direct response. 1.38e+12. What is the difference between the highest and the lowest Taxes (in $) in Norway?
Keep it short and to the point. 1.25e+11. What is the difference between the highest and the lowest Taxes (in $) of Suriname?
Your response must be concise. 6.50e+08. 